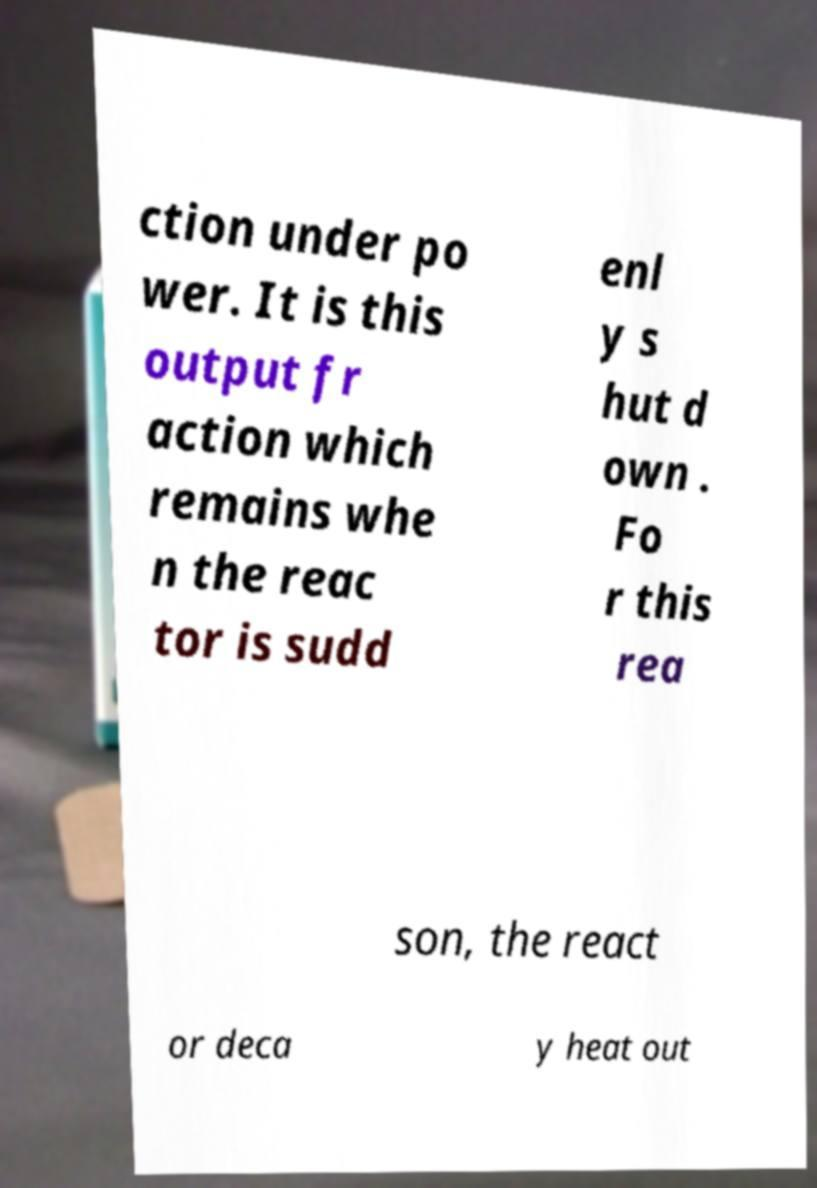Can you accurately transcribe the text from the provided image for me? ction under po wer. It is this output fr action which remains whe n the reac tor is sudd enl y s hut d own . Fo r this rea son, the react or deca y heat out 